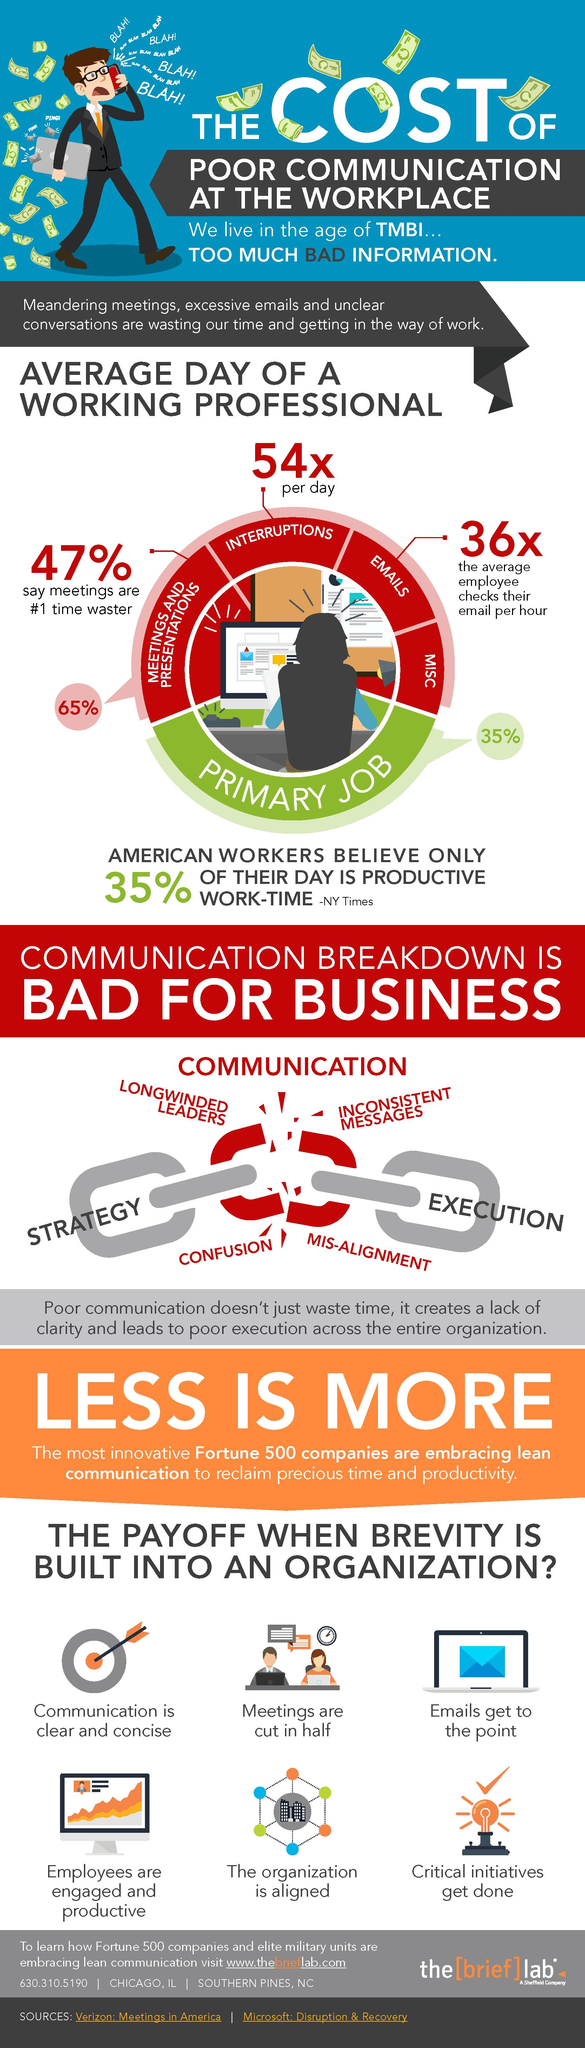Identify some key points in this picture. According to a belief among Americans, approximately 65% of the work day is considered unproductive. There are four listed disruptions against productive work time in the infographic. According to a survey, only 53% of organizations do not believe that meetings are the primary reason for wasting work time. 